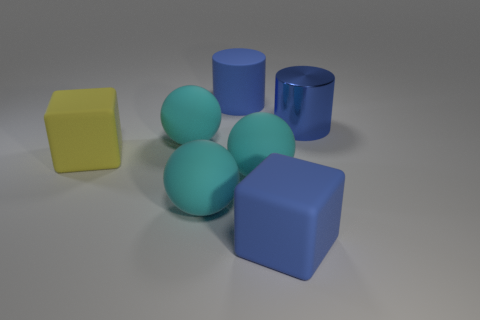Are the blue cube and the cyan sphere behind the yellow thing made of the same material?
Provide a short and direct response. Yes. Are there more big blue objects right of the big blue matte cube than cyan balls that are to the left of the large yellow thing?
Keep it short and to the point. Yes. The matte cylinder on the left side of the cylinder that is in front of the big matte cylinder is what color?
Make the answer very short. Blue. How many balls are either big cyan rubber objects or big blue objects?
Provide a succinct answer. 3. What number of objects are behind the large yellow thing and to the left of the large metal cylinder?
Offer a very short reply. 2. The big matte cube in front of the yellow rubber cube is what color?
Your answer should be compact. Blue. There is a blue block that is the same material as the large yellow thing; what is its size?
Offer a very short reply. Large. What number of big cyan rubber things are behind the large matte cube that is right of the large yellow thing?
Your answer should be very brief. 3. How many big blue objects are on the right side of the big rubber cylinder?
Provide a succinct answer. 2. What color is the big cylinder left of the large matte cube that is to the right of the big blue thing behind the shiny cylinder?
Your answer should be compact. Blue. 